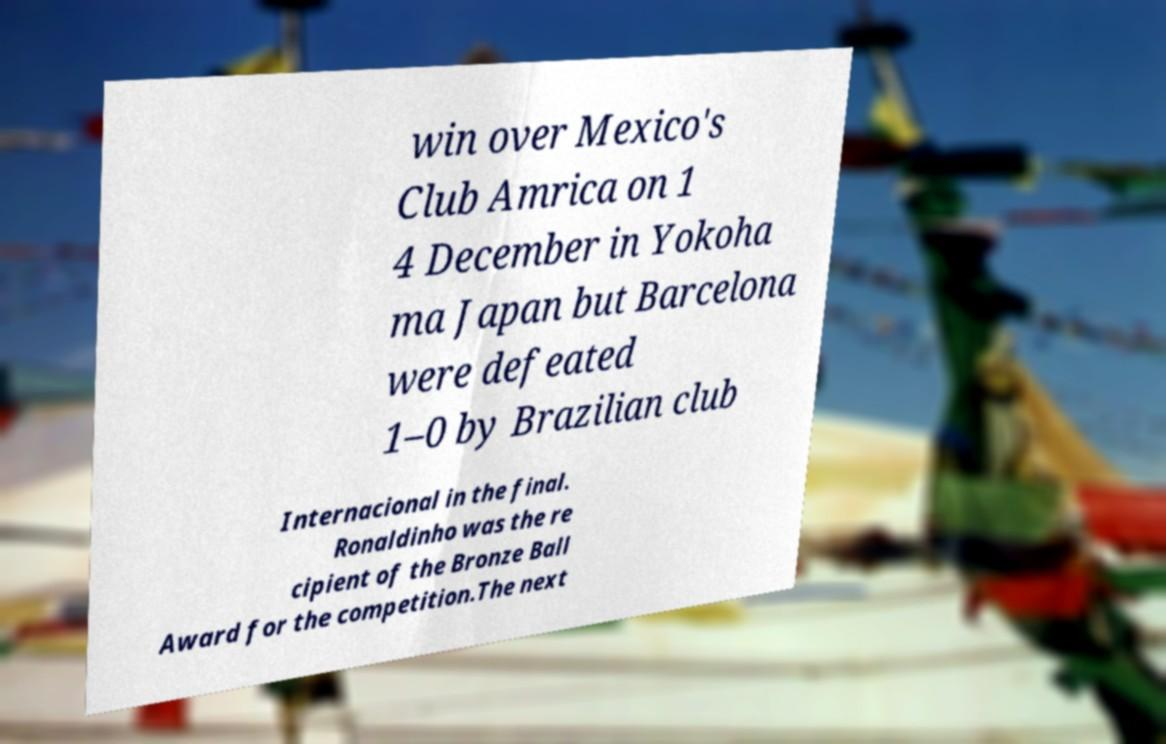Could you extract and type out the text from this image? win over Mexico's Club Amrica on 1 4 December in Yokoha ma Japan but Barcelona were defeated 1–0 by Brazilian club Internacional in the final. Ronaldinho was the re cipient of the Bronze Ball Award for the competition.The next 